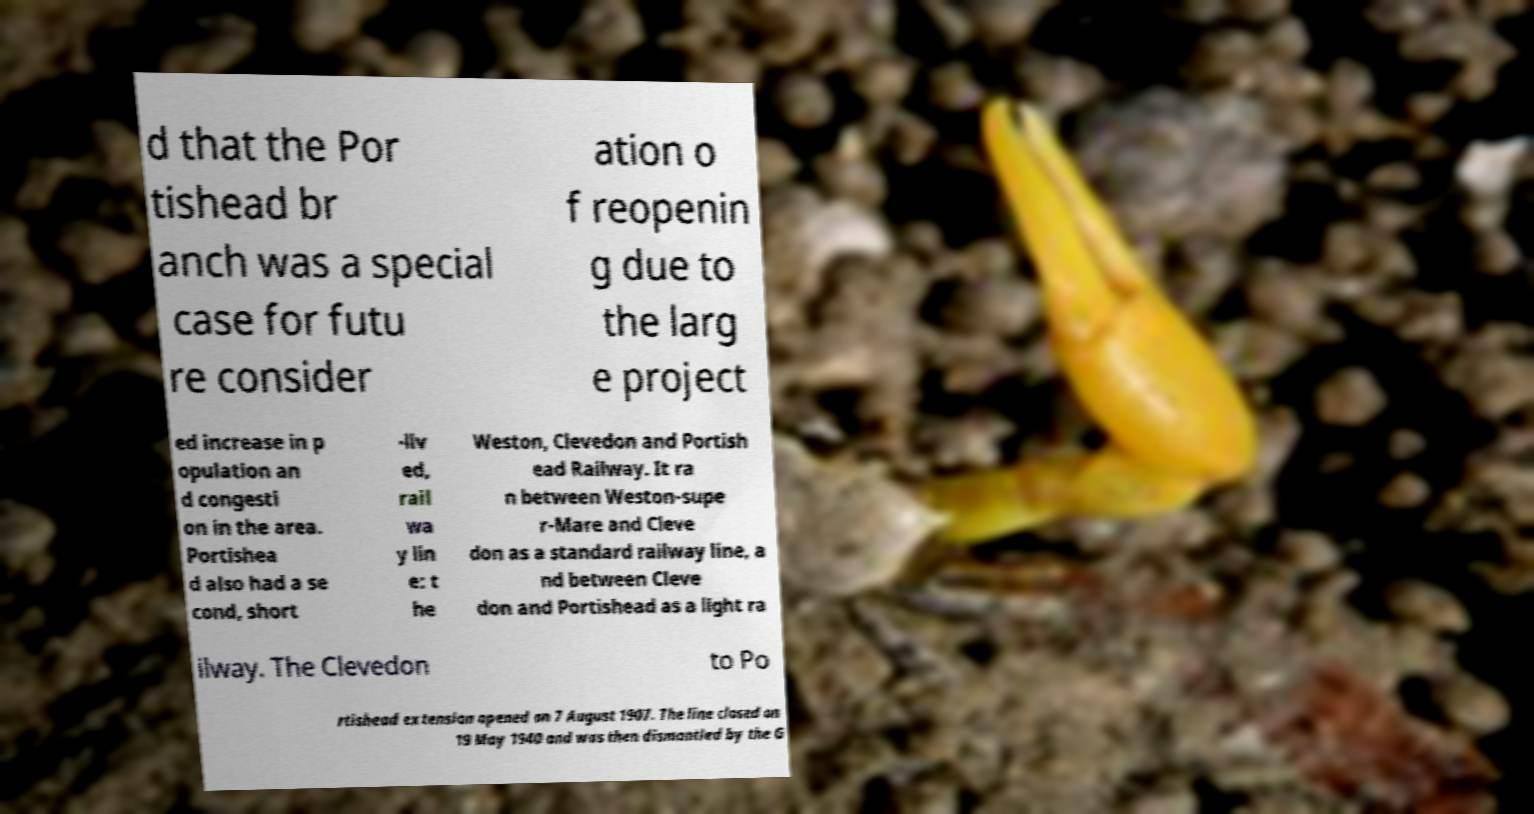What messages or text are displayed in this image? I need them in a readable, typed format. d that the Por tishead br anch was a special case for futu re consider ation o f reopenin g due to the larg e project ed increase in p opulation an d congesti on in the area. Portishea d also had a se cond, short -liv ed, rail wa y lin e: t he Weston, Clevedon and Portish ead Railway. It ra n between Weston-supe r-Mare and Cleve don as a standard railway line, a nd between Cleve don and Portishead as a light ra ilway. The Clevedon to Po rtishead extension opened on 7 August 1907. The line closed on 19 May 1940 and was then dismantled by the G 